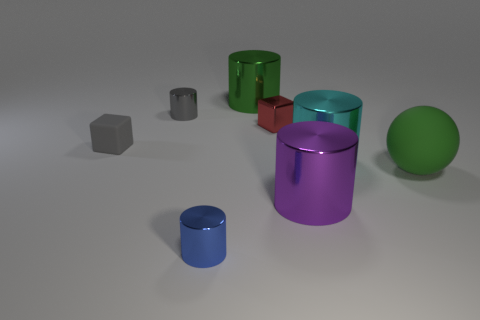Subtract all cyan metal cylinders. How many cylinders are left? 4 Subtract all green cylinders. How many cylinders are left? 4 Subtract all red cylinders. Subtract all brown spheres. How many cylinders are left? 5 Add 1 big cylinders. How many objects exist? 9 Subtract 0 blue spheres. How many objects are left? 8 Subtract all spheres. How many objects are left? 7 Subtract all tiny blue shiny cylinders. Subtract all large green rubber balls. How many objects are left? 6 Add 2 metal cylinders. How many metal cylinders are left? 7 Add 7 small gray shiny blocks. How many small gray shiny blocks exist? 7 